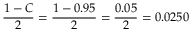Convert formula to latex. <formula><loc_0><loc_0><loc_500><loc_500>{ \frac { 1 - C } { 2 } } = { \frac { 1 - 0 . 9 5 } { 2 } } = { \frac { 0 . 0 5 } { 2 } } = 0 . 0 2 5 0</formula> 